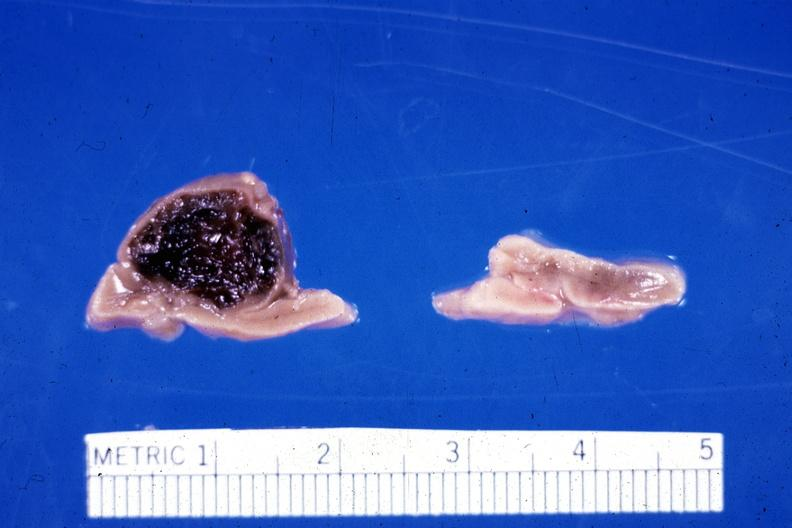what had ruptured causing 20 ml hemoperitoneum?
Answer the question using a single word or phrase. Adrenal of premature 30 week gestation gram infant lesion 